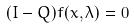Convert formula to latex. <formula><loc_0><loc_0><loc_500><loc_500>( I - Q ) f ( x , \lambda ) = 0</formula> 